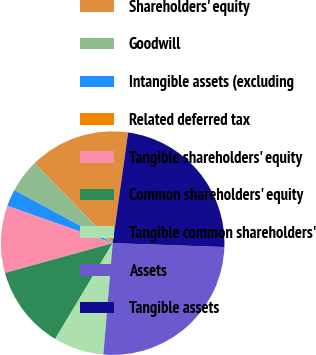<chart> <loc_0><loc_0><loc_500><loc_500><pie_chart><fcel>Shareholders' equity<fcel>Goodwill<fcel>Intangible assets (excluding<fcel>Related deferred tax<fcel>Tangible shareholders' equity<fcel>Common shareholders' equity<fcel>Tangible common shareholders'<fcel>Assets<fcel>Tangible assets<nl><fcel>14.51%<fcel>4.85%<fcel>2.44%<fcel>0.03%<fcel>9.68%<fcel>12.1%<fcel>7.27%<fcel>25.77%<fcel>23.35%<nl></chart> 